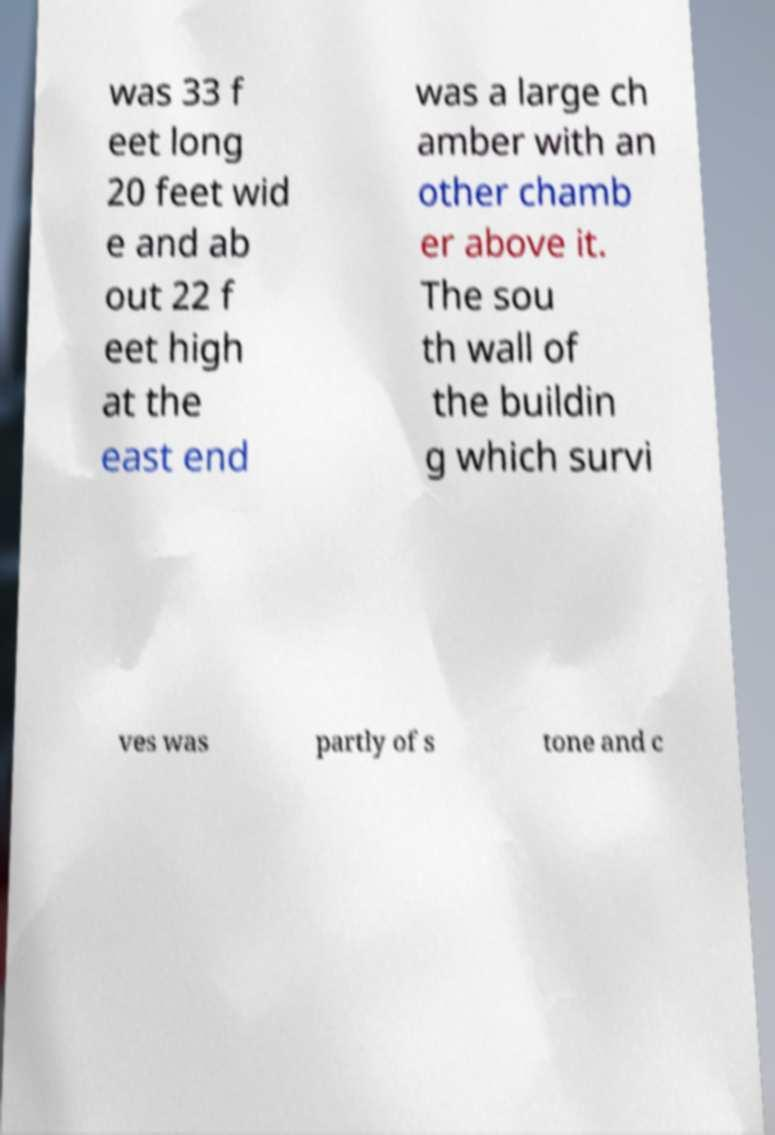Could you extract and type out the text from this image? was 33 f eet long 20 feet wid e and ab out 22 f eet high at the east end was a large ch amber with an other chamb er above it. The sou th wall of the buildin g which survi ves was partly of s tone and c 